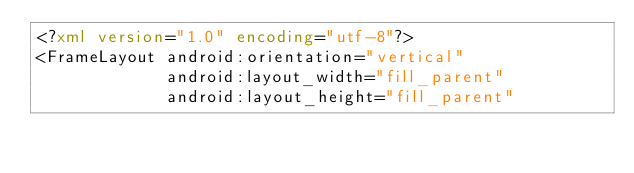<code> <loc_0><loc_0><loc_500><loc_500><_XML_><?xml version="1.0" encoding="utf-8"?>
<FrameLayout android:orientation="vertical"
             android:layout_width="fill_parent"
             android:layout_height="fill_parent"</code> 